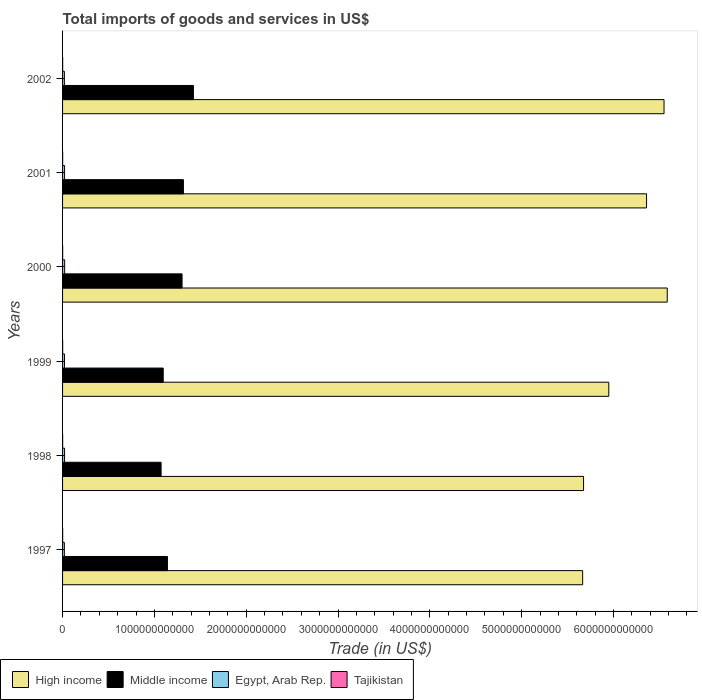How many bars are there on the 5th tick from the top?
Your answer should be compact. 4. How many bars are there on the 4th tick from the bottom?
Your response must be concise. 4. What is the total imports of goods and services in High income in 2000?
Your answer should be compact. 6.59e+12. Across all years, what is the maximum total imports of goods and services in Egypt, Arab Rep.?
Offer a terse response. 2.28e+1. Across all years, what is the minimum total imports of goods and services in Tajikistan?
Provide a short and direct response. 7.33e+08. In which year was the total imports of goods and services in Middle income minimum?
Offer a very short reply. 1998. What is the total total imports of goods and services in Middle income in the graph?
Your answer should be very brief. 7.35e+12. What is the difference between the total imports of goods and services in Tajikistan in 1999 and that in 2002?
Offer a very short reply. -1.96e+08. What is the difference between the total imports of goods and services in Tajikistan in 1998 and the total imports of goods and services in Egypt, Arab Rep. in 2002?
Provide a short and direct response. -1.92e+1. What is the average total imports of goods and services in High income per year?
Ensure brevity in your answer.  6.13e+12. In the year 2000, what is the difference between the total imports of goods and services in High income and total imports of goods and services in Egypt, Arab Rep.?
Ensure brevity in your answer.  6.56e+12. In how many years, is the total imports of goods and services in Egypt, Arab Rep. greater than 5600000000000 US$?
Provide a short and direct response. 0. What is the ratio of the total imports of goods and services in Tajikistan in 2001 to that in 2002?
Offer a very short reply. 0.91. Is the total imports of goods and services in Tajikistan in 1998 less than that in 2000?
Your answer should be compact. Yes. Is the difference between the total imports of goods and services in High income in 1997 and 2000 greater than the difference between the total imports of goods and services in Egypt, Arab Rep. in 1997 and 2000?
Your answer should be very brief. No. What is the difference between the highest and the second highest total imports of goods and services in High income?
Keep it short and to the point. 3.51e+1. What is the difference between the highest and the lowest total imports of goods and services in Middle income?
Your answer should be compact. 3.52e+11. Is the sum of the total imports of goods and services in Egypt, Arab Rep. in 1998 and 1999 greater than the maximum total imports of goods and services in Middle income across all years?
Keep it short and to the point. No. What does the 1st bar from the top in 2002 represents?
Provide a succinct answer. Tajikistan. Is it the case that in every year, the sum of the total imports of goods and services in High income and total imports of goods and services in Tajikistan is greater than the total imports of goods and services in Egypt, Arab Rep.?
Make the answer very short. Yes. How many bars are there?
Offer a very short reply. 24. How many years are there in the graph?
Offer a terse response. 6. What is the difference between two consecutive major ticks on the X-axis?
Offer a terse response. 1.00e+12. Does the graph contain grids?
Offer a terse response. No. Where does the legend appear in the graph?
Give a very brief answer. Bottom left. What is the title of the graph?
Offer a very short reply. Total imports of goods and services in US$. What is the label or title of the X-axis?
Your response must be concise. Trade (in US$). What is the Trade (in US$) of High income in 1997?
Keep it short and to the point. 5.66e+12. What is the Trade (in US$) in Middle income in 1997?
Provide a short and direct response. 1.14e+12. What is the Trade (in US$) in Egypt, Arab Rep. in 1997?
Make the answer very short. 1.95e+1. What is the Trade (in US$) in Tajikistan in 1997?
Your answer should be very brief. 8.66e+08. What is the Trade (in US$) of High income in 1998?
Your answer should be compact. 5.67e+12. What is the Trade (in US$) in Middle income in 1998?
Your answer should be compact. 1.07e+12. What is the Trade (in US$) of Egypt, Arab Rep. in 1998?
Make the answer very short. 2.18e+1. What is the Trade (in US$) of Tajikistan in 1998?
Ensure brevity in your answer.  7.66e+08. What is the Trade (in US$) of High income in 1999?
Your answer should be compact. 5.95e+12. What is the Trade (in US$) of Middle income in 1999?
Provide a short and direct response. 1.10e+12. What is the Trade (in US$) of Egypt, Arab Rep. in 1999?
Keep it short and to the point. 2.11e+1. What is the Trade (in US$) of Tajikistan in 1999?
Ensure brevity in your answer.  7.33e+08. What is the Trade (in US$) in High income in 2000?
Provide a succinct answer. 6.59e+12. What is the Trade (in US$) of Middle income in 2000?
Make the answer very short. 1.30e+12. What is the Trade (in US$) in Egypt, Arab Rep. in 2000?
Offer a very short reply. 2.28e+1. What is the Trade (in US$) in Tajikistan in 2000?
Offer a very short reply. 8.68e+08. What is the Trade (in US$) of High income in 2001?
Provide a succinct answer. 6.36e+12. What is the Trade (in US$) of Middle income in 2001?
Make the answer very short. 1.32e+12. What is the Trade (in US$) of Egypt, Arab Rep. in 2001?
Keep it short and to the point. 2.18e+1. What is the Trade (in US$) in Tajikistan in 2001?
Keep it short and to the point. 8.47e+08. What is the Trade (in US$) of High income in 2002?
Offer a very short reply. 6.55e+12. What is the Trade (in US$) in Middle income in 2002?
Give a very brief answer. 1.42e+12. What is the Trade (in US$) of Egypt, Arab Rep. in 2002?
Offer a very short reply. 1.99e+1. What is the Trade (in US$) of Tajikistan in 2002?
Your response must be concise. 9.29e+08. Across all years, what is the maximum Trade (in US$) of High income?
Make the answer very short. 6.59e+12. Across all years, what is the maximum Trade (in US$) in Middle income?
Your response must be concise. 1.42e+12. Across all years, what is the maximum Trade (in US$) of Egypt, Arab Rep.?
Ensure brevity in your answer.  2.28e+1. Across all years, what is the maximum Trade (in US$) of Tajikistan?
Make the answer very short. 9.29e+08. Across all years, what is the minimum Trade (in US$) of High income?
Give a very brief answer. 5.66e+12. Across all years, what is the minimum Trade (in US$) in Middle income?
Your response must be concise. 1.07e+12. Across all years, what is the minimum Trade (in US$) of Egypt, Arab Rep.?
Your response must be concise. 1.95e+1. Across all years, what is the minimum Trade (in US$) in Tajikistan?
Keep it short and to the point. 7.33e+08. What is the total Trade (in US$) of High income in the graph?
Provide a succinct answer. 3.68e+13. What is the total Trade (in US$) in Middle income in the graph?
Ensure brevity in your answer.  7.35e+12. What is the total Trade (in US$) of Egypt, Arab Rep. in the graph?
Ensure brevity in your answer.  1.27e+11. What is the total Trade (in US$) in Tajikistan in the graph?
Ensure brevity in your answer.  5.01e+09. What is the difference between the Trade (in US$) in High income in 1997 and that in 1998?
Offer a terse response. -9.92e+09. What is the difference between the Trade (in US$) in Middle income in 1997 and that in 1998?
Give a very brief answer. 6.91e+1. What is the difference between the Trade (in US$) of Egypt, Arab Rep. in 1997 and that in 1998?
Keep it short and to the point. -2.28e+09. What is the difference between the Trade (in US$) in Tajikistan in 1997 and that in 1998?
Keep it short and to the point. 9.98e+07. What is the difference between the Trade (in US$) of High income in 1997 and that in 1999?
Provide a short and direct response. -2.85e+11. What is the difference between the Trade (in US$) of Middle income in 1997 and that in 1999?
Keep it short and to the point. 4.58e+1. What is the difference between the Trade (in US$) in Egypt, Arab Rep. in 1997 and that in 1999?
Offer a terse response. -1.62e+09. What is the difference between the Trade (in US$) of Tajikistan in 1997 and that in 1999?
Ensure brevity in your answer.  1.32e+08. What is the difference between the Trade (in US$) of High income in 1997 and that in 2000?
Make the answer very short. -9.21e+11. What is the difference between the Trade (in US$) in Middle income in 1997 and that in 2000?
Your answer should be compact. -1.59e+11. What is the difference between the Trade (in US$) in Egypt, Arab Rep. in 1997 and that in 2000?
Give a very brief answer. -3.25e+09. What is the difference between the Trade (in US$) in Tajikistan in 1997 and that in 2000?
Offer a very short reply. -2.83e+06. What is the difference between the Trade (in US$) of High income in 1997 and that in 2001?
Provide a succinct answer. -6.96e+11. What is the difference between the Trade (in US$) in Middle income in 1997 and that in 2001?
Provide a succinct answer. -1.74e+11. What is the difference between the Trade (in US$) of Egypt, Arab Rep. in 1997 and that in 2001?
Your response must be concise. -2.27e+09. What is the difference between the Trade (in US$) of Tajikistan in 1997 and that in 2001?
Provide a succinct answer. 1.87e+07. What is the difference between the Trade (in US$) of High income in 1997 and that in 2002?
Your answer should be compact. -8.86e+11. What is the difference between the Trade (in US$) of Middle income in 1997 and that in 2002?
Your response must be concise. -2.83e+11. What is the difference between the Trade (in US$) of Egypt, Arab Rep. in 1997 and that in 2002?
Your answer should be compact. -3.89e+08. What is the difference between the Trade (in US$) in Tajikistan in 1997 and that in 2002?
Provide a succinct answer. -6.36e+07. What is the difference between the Trade (in US$) of High income in 1998 and that in 1999?
Your answer should be very brief. -2.75e+11. What is the difference between the Trade (in US$) of Middle income in 1998 and that in 1999?
Offer a very short reply. -2.33e+1. What is the difference between the Trade (in US$) of Egypt, Arab Rep. in 1998 and that in 1999?
Provide a short and direct response. 6.68e+08. What is the difference between the Trade (in US$) in Tajikistan in 1998 and that in 1999?
Ensure brevity in your answer.  3.23e+07. What is the difference between the Trade (in US$) of High income in 1998 and that in 2000?
Give a very brief answer. -9.12e+11. What is the difference between the Trade (in US$) of Middle income in 1998 and that in 2000?
Give a very brief answer. -2.28e+11. What is the difference between the Trade (in US$) in Egypt, Arab Rep. in 1998 and that in 2000?
Your answer should be compact. -9.68e+08. What is the difference between the Trade (in US$) of Tajikistan in 1998 and that in 2000?
Make the answer very short. -1.03e+08. What is the difference between the Trade (in US$) of High income in 1998 and that in 2001?
Your answer should be very brief. -6.86e+11. What is the difference between the Trade (in US$) of Middle income in 1998 and that in 2001?
Give a very brief answer. -2.43e+11. What is the difference between the Trade (in US$) in Egypt, Arab Rep. in 1998 and that in 2001?
Make the answer very short. 1.04e+07. What is the difference between the Trade (in US$) in Tajikistan in 1998 and that in 2001?
Keep it short and to the point. -8.11e+07. What is the difference between the Trade (in US$) of High income in 1998 and that in 2002?
Provide a succinct answer. -8.76e+11. What is the difference between the Trade (in US$) in Middle income in 1998 and that in 2002?
Offer a very short reply. -3.52e+11. What is the difference between the Trade (in US$) of Egypt, Arab Rep. in 1998 and that in 2002?
Your answer should be compact. 1.90e+09. What is the difference between the Trade (in US$) of Tajikistan in 1998 and that in 2002?
Offer a terse response. -1.63e+08. What is the difference between the Trade (in US$) of High income in 1999 and that in 2000?
Provide a short and direct response. -6.37e+11. What is the difference between the Trade (in US$) of Middle income in 1999 and that in 2000?
Provide a short and direct response. -2.05e+11. What is the difference between the Trade (in US$) of Egypt, Arab Rep. in 1999 and that in 2000?
Your response must be concise. -1.64e+09. What is the difference between the Trade (in US$) of Tajikistan in 1999 and that in 2000?
Make the answer very short. -1.35e+08. What is the difference between the Trade (in US$) of High income in 1999 and that in 2001?
Your response must be concise. -4.11e+11. What is the difference between the Trade (in US$) in Middle income in 1999 and that in 2001?
Your answer should be compact. -2.20e+11. What is the difference between the Trade (in US$) of Egypt, Arab Rep. in 1999 and that in 2001?
Make the answer very short. -6.58e+08. What is the difference between the Trade (in US$) in Tajikistan in 1999 and that in 2001?
Offer a very short reply. -1.13e+08. What is the difference between the Trade (in US$) in High income in 1999 and that in 2002?
Offer a terse response. -6.02e+11. What is the difference between the Trade (in US$) of Middle income in 1999 and that in 2002?
Provide a succinct answer. -3.29e+11. What is the difference between the Trade (in US$) of Egypt, Arab Rep. in 1999 and that in 2002?
Offer a terse response. 1.23e+09. What is the difference between the Trade (in US$) of Tajikistan in 1999 and that in 2002?
Your response must be concise. -1.96e+08. What is the difference between the Trade (in US$) of High income in 2000 and that in 2001?
Give a very brief answer. 2.26e+11. What is the difference between the Trade (in US$) of Middle income in 2000 and that in 2001?
Offer a terse response. -1.48e+1. What is the difference between the Trade (in US$) in Egypt, Arab Rep. in 2000 and that in 2001?
Provide a succinct answer. 9.78e+08. What is the difference between the Trade (in US$) in Tajikistan in 2000 and that in 2001?
Offer a very short reply. 2.15e+07. What is the difference between the Trade (in US$) of High income in 2000 and that in 2002?
Make the answer very short. 3.51e+1. What is the difference between the Trade (in US$) of Middle income in 2000 and that in 2002?
Ensure brevity in your answer.  -1.24e+11. What is the difference between the Trade (in US$) in Egypt, Arab Rep. in 2000 and that in 2002?
Keep it short and to the point. 2.86e+09. What is the difference between the Trade (in US$) in Tajikistan in 2000 and that in 2002?
Your answer should be very brief. -6.08e+07. What is the difference between the Trade (in US$) in High income in 2001 and that in 2002?
Your response must be concise. -1.90e+11. What is the difference between the Trade (in US$) in Middle income in 2001 and that in 2002?
Provide a short and direct response. -1.09e+11. What is the difference between the Trade (in US$) of Egypt, Arab Rep. in 2001 and that in 2002?
Provide a short and direct response. 1.89e+09. What is the difference between the Trade (in US$) of Tajikistan in 2001 and that in 2002?
Your answer should be compact. -8.23e+07. What is the difference between the Trade (in US$) of High income in 1997 and the Trade (in US$) of Middle income in 1998?
Your answer should be compact. 4.59e+12. What is the difference between the Trade (in US$) of High income in 1997 and the Trade (in US$) of Egypt, Arab Rep. in 1998?
Your response must be concise. 5.64e+12. What is the difference between the Trade (in US$) in High income in 1997 and the Trade (in US$) in Tajikistan in 1998?
Keep it short and to the point. 5.66e+12. What is the difference between the Trade (in US$) of Middle income in 1997 and the Trade (in US$) of Egypt, Arab Rep. in 1998?
Your answer should be very brief. 1.12e+12. What is the difference between the Trade (in US$) in Middle income in 1997 and the Trade (in US$) in Tajikistan in 1998?
Provide a short and direct response. 1.14e+12. What is the difference between the Trade (in US$) in Egypt, Arab Rep. in 1997 and the Trade (in US$) in Tajikistan in 1998?
Your response must be concise. 1.88e+1. What is the difference between the Trade (in US$) in High income in 1997 and the Trade (in US$) in Middle income in 1999?
Your answer should be very brief. 4.57e+12. What is the difference between the Trade (in US$) of High income in 1997 and the Trade (in US$) of Egypt, Arab Rep. in 1999?
Ensure brevity in your answer.  5.64e+12. What is the difference between the Trade (in US$) of High income in 1997 and the Trade (in US$) of Tajikistan in 1999?
Offer a very short reply. 5.66e+12. What is the difference between the Trade (in US$) in Middle income in 1997 and the Trade (in US$) in Egypt, Arab Rep. in 1999?
Your answer should be compact. 1.12e+12. What is the difference between the Trade (in US$) of Middle income in 1997 and the Trade (in US$) of Tajikistan in 1999?
Your answer should be very brief. 1.14e+12. What is the difference between the Trade (in US$) of Egypt, Arab Rep. in 1997 and the Trade (in US$) of Tajikistan in 1999?
Your response must be concise. 1.88e+1. What is the difference between the Trade (in US$) in High income in 1997 and the Trade (in US$) in Middle income in 2000?
Ensure brevity in your answer.  4.36e+12. What is the difference between the Trade (in US$) of High income in 1997 and the Trade (in US$) of Egypt, Arab Rep. in 2000?
Ensure brevity in your answer.  5.64e+12. What is the difference between the Trade (in US$) of High income in 1997 and the Trade (in US$) of Tajikistan in 2000?
Your response must be concise. 5.66e+12. What is the difference between the Trade (in US$) of Middle income in 1997 and the Trade (in US$) of Egypt, Arab Rep. in 2000?
Your answer should be very brief. 1.12e+12. What is the difference between the Trade (in US$) in Middle income in 1997 and the Trade (in US$) in Tajikistan in 2000?
Offer a very short reply. 1.14e+12. What is the difference between the Trade (in US$) in Egypt, Arab Rep. in 1997 and the Trade (in US$) in Tajikistan in 2000?
Provide a short and direct response. 1.87e+1. What is the difference between the Trade (in US$) in High income in 1997 and the Trade (in US$) in Middle income in 2001?
Ensure brevity in your answer.  4.35e+12. What is the difference between the Trade (in US$) of High income in 1997 and the Trade (in US$) of Egypt, Arab Rep. in 2001?
Offer a terse response. 5.64e+12. What is the difference between the Trade (in US$) in High income in 1997 and the Trade (in US$) in Tajikistan in 2001?
Make the answer very short. 5.66e+12. What is the difference between the Trade (in US$) of Middle income in 1997 and the Trade (in US$) of Egypt, Arab Rep. in 2001?
Provide a succinct answer. 1.12e+12. What is the difference between the Trade (in US$) of Middle income in 1997 and the Trade (in US$) of Tajikistan in 2001?
Offer a terse response. 1.14e+12. What is the difference between the Trade (in US$) in Egypt, Arab Rep. in 1997 and the Trade (in US$) in Tajikistan in 2001?
Keep it short and to the point. 1.87e+1. What is the difference between the Trade (in US$) of High income in 1997 and the Trade (in US$) of Middle income in 2002?
Provide a short and direct response. 4.24e+12. What is the difference between the Trade (in US$) in High income in 1997 and the Trade (in US$) in Egypt, Arab Rep. in 2002?
Your answer should be very brief. 5.64e+12. What is the difference between the Trade (in US$) of High income in 1997 and the Trade (in US$) of Tajikistan in 2002?
Give a very brief answer. 5.66e+12. What is the difference between the Trade (in US$) of Middle income in 1997 and the Trade (in US$) of Egypt, Arab Rep. in 2002?
Give a very brief answer. 1.12e+12. What is the difference between the Trade (in US$) of Middle income in 1997 and the Trade (in US$) of Tajikistan in 2002?
Offer a terse response. 1.14e+12. What is the difference between the Trade (in US$) of Egypt, Arab Rep. in 1997 and the Trade (in US$) of Tajikistan in 2002?
Offer a terse response. 1.86e+1. What is the difference between the Trade (in US$) of High income in 1998 and the Trade (in US$) of Middle income in 1999?
Keep it short and to the point. 4.58e+12. What is the difference between the Trade (in US$) of High income in 1998 and the Trade (in US$) of Egypt, Arab Rep. in 1999?
Offer a very short reply. 5.65e+12. What is the difference between the Trade (in US$) in High income in 1998 and the Trade (in US$) in Tajikistan in 1999?
Offer a very short reply. 5.67e+12. What is the difference between the Trade (in US$) of Middle income in 1998 and the Trade (in US$) of Egypt, Arab Rep. in 1999?
Offer a terse response. 1.05e+12. What is the difference between the Trade (in US$) in Middle income in 1998 and the Trade (in US$) in Tajikistan in 1999?
Your answer should be very brief. 1.07e+12. What is the difference between the Trade (in US$) in Egypt, Arab Rep. in 1998 and the Trade (in US$) in Tajikistan in 1999?
Your answer should be very brief. 2.11e+1. What is the difference between the Trade (in US$) of High income in 1998 and the Trade (in US$) of Middle income in 2000?
Your response must be concise. 4.37e+12. What is the difference between the Trade (in US$) of High income in 1998 and the Trade (in US$) of Egypt, Arab Rep. in 2000?
Make the answer very short. 5.65e+12. What is the difference between the Trade (in US$) of High income in 1998 and the Trade (in US$) of Tajikistan in 2000?
Offer a very short reply. 5.67e+12. What is the difference between the Trade (in US$) of Middle income in 1998 and the Trade (in US$) of Egypt, Arab Rep. in 2000?
Offer a very short reply. 1.05e+12. What is the difference between the Trade (in US$) of Middle income in 1998 and the Trade (in US$) of Tajikistan in 2000?
Make the answer very short. 1.07e+12. What is the difference between the Trade (in US$) in Egypt, Arab Rep. in 1998 and the Trade (in US$) in Tajikistan in 2000?
Your response must be concise. 2.09e+1. What is the difference between the Trade (in US$) of High income in 1998 and the Trade (in US$) of Middle income in 2001?
Your answer should be compact. 4.36e+12. What is the difference between the Trade (in US$) in High income in 1998 and the Trade (in US$) in Egypt, Arab Rep. in 2001?
Keep it short and to the point. 5.65e+12. What is the difference between the Trade (in US$) of High income in 1998 and the Trade (in US$) of Tajikistan in 2001?
Your response must be concise. 5.67e+12. What is the difference between the Trade (in US$) in Middle income in 1998 and the Trade (in US$) in Egypt, Arab Rep. in 2001?
Provide a succinct answer. 1.05e+12. What is the difference between the Trade (in US$) in Middle income in 1998 and the Trade (in US$) in Tajikistan in 2001?
Your answer should be compact. 1.07e+12. What is the difference between the Trade (in US$) in Egypt, Arab Rep. in 1998 and the Trade (in US$) in Tajikistan in 2001?
Give a very brief answer. 2.10e+1. What is the difference between the Trade (in US$) in High income in 1998 and the Trade (in US$) in Middle income in 2002?
Your response must be concise. 4.25e+12. What is the difference between the Trade (in US$) in High income in 1998 and the Trade (in US$) in Egypt, Arab Rep. in 2002?
Your response must be concise. 5.65e+12. What is the difference between the Trade (in US$) of High income in 1998 and the Trade (in US$) of Tajikistan in 2002?
Make the answer very short. 5.67e+12. What is the difference between the Trade (in US$) in Middle income in 1998 and the Trade (in US$) in Egypt, Arab Rep. in 2002?
Your response must be concise. 1.05e+12. What is the difference between the Trade (in US$) in Middle income in 1998 and the Trade (in US$) in Tajikistan in 2002?
Offer a very short reply. 1.07e+12. What is the difference between the Trade (in US$) of Egypt, Arab Rep. in 1998 and the Trade (in US$) of Tajikistan in 2002?
Your answer should be compact. 2.09e+1. What is the difference between the Trade (in US$) of High income in 1999 and the Trade (in US$) of Middle income in 2000?
Keep it short and to the point. 4.65e+12. What is the difference between the Trade (in US$) of High income in 1999 and the Trade (in US$) of Egypt, Arab Rep. in 2000?
Provide a succinct answer. 5.93e+12. What is the difference between the Trade (in US$) of High income in 1999 and the Trade (in US$) of Tajikistan in 2000?
Ensure brevity in your answer.  5.95e+12. What is the difference between the Trade (in US$) of Middle income in 1999 and the Trade (in US$) of Egypt, Arab Rep. in 2000?
Provide a short and direct response. 1.07e+12. What is the difference between the Trade (in US$) in Middle income in 1999 and the Trade (in US$) in Tajikistan in 2000?
Your answer should be very brief. 1.10e+12. What is the difference between the Trade (in US$) of Egypt, Arab Rep. in 1999 and the Trade (in US$) of Tajikistan in 2000?
Offer a terse response. 2.03e+1. What is the difference between the Trade (in US$) of High income in 1999 and the Trade (in US$) of Middle income in 2001?
Provide a short and direct response. 4.63e+12. What is the difference between the Trade (in US$) in High income in 1999 and the Trade (in US$) in Egypt, Arab Rep. in 2001?
Your answer should be very brief. 5.93e+12. What is the difference between the Trade (in US$) in High income in 1999 and the Trade (in US$) in Tajikistan in 2001?
Your response must be concise. 5.95e+12. What is the difference between the Trade (in US$) in Middle income in 1999 and the Trade (in US$) in Egypt, Arab Rep. in 2001?
Offer a very short reply. 1.07e+12. What is the difference between the Trade (in US$) in Middle income in 1999 and the Trade (in US$) in Tajikistan in 2001?
Offer a very short reply. 1.10e+12. What is the difference between the Trade (in US$) of Egypt, Arab Rep. in 1999 and the Trade (in US$) of Tajikistan in 2001?
Make the answer very short. 2.03e+1. What is the difference between the Trade (in US$) in High income in 1999 and the Trade (in US$) in Middle income in 2002?
Keep it short and to the point. 4.52e+12. What is the difference between the Trade (in US$) in High income in 1999 and the Trade (in US$) in Egypt, Arab Rep. in 2002?
Give a very brief answer. 5.93e+12. What is the difference between the Trade (in US$) in High income in 1999 and the Trade (in US$) in Tajikistan in 2002?
Make the answer very short. 5.95e+12. What is the difference between the Trade (in US$) in Middle income in 1999 and the Trade (in US$) in Egypt, Arab Rep. in 2002?
Provide a short and direct response. 1.08e+12. What is the difference between the Trade (in US$) in Middle income in 1999 and the Trade (in US$) in Tajikistan in 2002?
Provide a short and direct response. 1.10e+12. What is the difference between the Trade (in US$) in Egypt, Arab Rep. in 1999 and the Trade (in US$) in Tajikistan in 2002?
Provide a short and direct response. 2.02e+1. What is the difference between the Trade (in US$) in High income in 2000 and the Trade (in US$) in Middle income in 2001?
Keep it short and to the point. 5.27e+12. What is the difference between the Trade (in US$) of High income in 2000 and the Trade (in US$) of Egypt, Arab Rep. in 2001?
Ensure brevity in your answer.  6.56e+12. What is the difference between the Trade (in US$) in High income in 2000 and the Trade (in US$) in Tajikistan in 2001?
Provide a short and direct response. 6.58e+12. What is the difference between the Trade (in US$) in Middle income in 2000 and the Trade (in US$) in Egypt, Arab Rep. in 2001?
Make the answer very short. 1.28e+12. What is the difference between the Trade (in US$) of Middle income in 2000 and the Trade (in US$) of Tajikistan in 2001?
Your answer should be compact. 1.30e+12. What is the difference between the Trade (in US$) in Egypt, Arab Rep. in 2000 and the Trade (in US$) in Tajikistan in 2001?
Your answer should be very brief. 2.19e+1. What is the difference between the Trade (in US$) in High income in 2000 and the Trade (in US$) in Middle income in 2002?
Ensure brevity in your answer.  5.16e+12. What is the difference between the Trade (in US$) of High income in 2000 and the Trade (in US$) of Egypt, Arab Rep. in 2002?
Give a very brief answer. 6.57e+12. What is the difference between the Trade (in US$) in High income in 2000 and the Trade (in US$) in Tajikistan in 2002?
Your answer should be compact. 6.58e+12. What is the difference between the Trade (in US$) in Middle income in 2000 and the Trade (in US$) in Egypt, Arab Rep. in 2002?
Provide a short and direct response. 1.28e+12. What is the difference between the Trade (in US$) of Middle income in 2000 and the Trade (in US$) of Tajikistan in 2002?
Offer a terse response. 1.30e+12. What is the difference between the Trade (in US$) in Egypt, Arab Rep. in 2000 and the Trade (in US$) in Tajikistan in 2002?
Your answer should be very brief. 2.19e+1. What is the difference between the Trade (in US$) in High income in 2001 and the Trade (in US$) in Middle income in 2002?
Offer a very short reply. 4.94e+12. What is the difference between the Trade (in US$) of High income in 2001 and the Trade (in US$) of Egypt, Arab Rep. in 2002?
Offer a very short reply. 6.34e+12. What is the difference between the Trade (in US$) in High income in 2001 and the Trade (in US$) in Tajikistan in 2002?
Give a very brief answer. 6.36e+12. What is the difference between the Trade (in US$) in Middle income in 2001 and the Trade (in US$) in Egypt, Arab Rep. in 2002?
Keep it short and to the point. 1.30e+12. What is the difference between the Trade (in US$) in Middle income in 2001 and the Trade (in US$) in Tajikistan in 2002?
Offer a very short reply. 1.32e+12. What is the difference between the Trade (in US$) in Egypt, Arab Rep. in 2001 and the Trade (in US$) in Tajikistan in 2002?
Give a very brief answer. 2.09e+1. What is the average Trade (in US$) in High income per year?
Offer a terse response. 6.13e+12. What is the average Trade (in US$) in Middle income per year?
Provide a short and direct response. 1.23e+12. What is the average Trade (in US$) in Egypt, Arab Rep. per year?
Provide a short and direct response. 2.12e+1. What is the average Trade (in US$) in Tajikistan per year?
Your response must be concise. 8.35e+08. In the year 1997, what is the difference between the Trade (in US$) of High income and Trade (in US$) of Middle income?
Give a very brief answer. 4.52e+12. In the year 1997, what is the difference between the Trade (in US$) in High income and Trade (in US$) in Egypt, Arab Rep.?
Ensure brevity in your answer.  5.64e+12. In the year 1997, what is the difference between the Trade (in US$) in High income and Trade (in US$) in Tajikistan?
Give a very brief answer. 5.66e+12. In the year 1997, what is the difference between the Trade (in US$) in Middle income and Trade (in US$) in Egypt, Arab Rep.?
Give a very brief answer. 1.12e+12. In the year 1997, what is the difference between the Trade (in US$) of Middle income and Trade (in US$) of Tajikistan?
Provide a short and direct response. 1.14e+12. In the year 1997, what is the difference between the Trade (in US$) of Egypt, Arab Rep. and Trade (in US$) of Tajikistan?
Your response must be concise. 1.87e+1. In the year 1998, what is the difference between the Trade (in US$) in High income and Trade (in US$) in Middle income?
Provide a short and direct response. 4.60e+12. In the year 1998, what is the difference between the Trade (in US$) in High income and Trade (in US$) in Egypt, Arab Rep.?
Your response must be concise. 5.65e+12. In the year 1998, what is the difference between the Trade (in US$) of High income and Trade (in US$) of Tajikistan?
Your answer should be very brief. 5.67e+12. In the year 1998, what is the difference between the Trade (in US$) of Middle income and Trade (in US$) of Egypt, Arab Rep.?
Make the answer very short. 1.05e+12. In the year 1998, what is the difference between the Trade (in US$) in Middle income and Trade (in US$) in Tajikistan?
Make the answer very short. 1.07e+12. In the year 1998, what is the difference between the Trade (in US$) of Egypt, Arab Rep. and Trade (in US$) of Tajikistan?
Provide a short and direct response. 2.10e+1. In the year 1999, what is the difference between the Trade (in US$) in High income and Trade (in US$) in Middle income?
Provide a succinct answer. 4.85e+12. In the year 1999, what is the difference between the Trade (in US$) in High income and Trade (in US$) in Egypt, Arab Rep.?
Keep it short and to the point. 5.93e+12. In the year 1999, what is the difference between the Trade (in US$) of High income and Trade (in US$) of Tajikistan?
Provide a succinct answer. 5.95e+12. In the year 1999, what is the difference between the Trade (in US$) in Middle income and Trade (in US$) in Egypt, Arab Rep.?
Provide a short and direct response. 1.08e+12. In the year 1999, what is the difference between the Trade (in US$) in Middle income and Trade (in US$) in Tajikistan?
Ensure brevity in your answer.  1.10e+12. In the year 1999, what is the difference between the Trade (in US$) of Egypt, Arab Rep. and Trade (in US$) of Tajikistan?
Keep it short and to the point. 2.04e+1. In the year 2000, what is the difference between the Trade (in US$) of High income and Trade (in US$) of Middle income?
Your answer should be very brief. 5.28e+12. In the year 2000, what is the difference between the Trade (in US$) in High income and Trade (in US$) in Egypt, Arab Rep.?
Make the answer very short. 6.56e+12. In the year 2000, what is the difference between the Trade (in US$) in High income and Trade (in US$) in Tajikistan?
Your answer should be compact. 6.58e+12. In the year 2000, what is the difference between the Trade (in US$) in Middle income and Trade (in US$) in Egypt, Arab Rep.?
Provide a short and direct response. 1.28e+12. In the year 2000, what is the difference between the Trade (in US$) of Middle income and Trade (in US$) of Tajikistan?
Offer a terse response. 1.30e+12. In the year 2000, what is the difference between the Trade (in US$) of Egypt, Arab Rep. and Trade (in US$) of Tajikistan?
Offer a very short reply. 2.19e+1. In the year 2001, what is the difference between the Trade (in US$) in High income and Trade (in US$) in Middle income?
Make the answer very short. 5.04e+12. In the year 2001, what is the difference between the Trade (in US$) in High income and Trade (in US$) in Egypt, Arab Rep.?
Give a very brief answer. 6.34e+12. In the year 2001, what is the difference between the Trade (in US$) in High income and Trade (in US$) in Tajikistan?
Ensure brevity in your answer.  6.36e+12. In the year 2001, what is the difference between the Trade (in US$) of Middle income and Trade (in US$) of Egypt, Arab Rep.?
Offer a very short reply. 1.29e+12. In the year 2001, what is the difference between the Trade (in US$) of Middle income and Trade (in US$) of Tajikistan?
Your response must be concise. 1.32e+12. In the year 2001, what is the difference between the Trade (in US$) in Egypt, Arab Rep. and Trade (in US$) in Tajikistan?
Give a very brief answer. 2.10e+1. In the year 2002, what is the difference between the Trade (in US$) in High income and Trade (in US$) in Middle income?
Offer a terse response. 5.13e+12. In the year 2002, what is the difference between the Trade (in US$) in High income and Trade (in US$) in Egypt, Arab Rep.?
Provide a succinct answer. 6.53e+12. In the year 2002, what is the difference between the Trade (in US$) in High income and Trade (in US$) in Tajikistan?
Keep it short and to the point. 6.55e+12. In the year 2002, what is the difference between the Trade (in US$) in Middle income and Trade (in US$) in Egypt, Arab Rep.?
Provide a short and direct response. 1.41e+12. In the year 2002, what is the difference between the Trade (in US$) in Middle income and Trade (in US$) in Tajikistan?
Your answer should be very brief. 1.42e+12. In the year 2002, what is the difference between the Trade (in US$) in Egypt, Arab Rep. and Trade (in US$) in Tajikistan?
Ensure brevity in your answer.  1.90e+1. What is the ratio of the Trade (in US$) in High income in 1997 to that in 1998?
Provide a short and direct response. 1. What is the ratio of the Trade (in US$) of Middle income in 1997 to that in 1998?
Give a very brief answer. 1.06. What is the ratio of the Trade (in US$) in Egypt, Arab Rep. in 1997 to that in 1998?
Your response must be concise. 0.9. What is the ratio of the Trade (in US$) of Tajikistan in 1997 to that in 1998?
Ensure brevity in your answer.  1.13. What is the ratio of the Trade (in US$) of High income in 1997 to that in 1999?
Keep it short and to the point. 0.95. What is the ratio of the Trade (in US$) of Middle income in 1997 to that in 1999?
Offer a very short reply. 1.04. What is the ratio of the Trade (in US$) of Egypt, Arab Rep. in 1997 to that in 1999?
Your answer should be compact. 0.92. What is the ratio of the Trade (in US$) of Tajikistan in 1997 to that in 1999?
Provide a succinct answer. 1.18. What is the ratio of the Trade (in US$) in High income in 1997 to that in 2000?
Keep it short and to the point. 0.86. What is the ratio of the Trade (in US$) in Middle income in 1997 to that in 2000?
Offer a terse response. 0.88. What is the ratio of the Trade (in US$) in Egypt, Arab Rep. in 1997 to that in 2000?
Keep it short and to the point. 0.86. What is the ratio of the Trade (in US$) in Tajikistan in 1997 to that in 2000?
Your answer should be very brief. 1. What is the ratio of the Trade (in US$) of High income in 1997 to that in 2001?
Make the answer very short. 0.89. What is the ratio of the Trade (in US$) of Middle income in 1997 to that in 2001?
Your response must be concise. 0.87. What is the ratio of the Trade (in US$) in Egypt, Arab Rep. in 1997 to that in 2001?
Ensure brevity in your answer.  0.9. What is the ratio of the Trade (in US$) of Tajikistan in 1997 to that in 2001?
Offer a terse response. 1.02. What is the ratio of the Trade (in US$) of High income in 1997 to that in 2002?
Offer a very short reply. 0.86. What is the ratio of the Trade (in US$) of Middle income in 1997 to that in 2002?
Your answer should be very brief. 0.8. What is the ratio of the Trade (in US$) in Egypt, Arab Rep. in 1997 to that in 2002?
Give a very brief answer. 0.98. What is the ratio of the Trade (in US$) in Tajikistan in 1997 to that in 2002?
Make the answer very short. 0.93. What is the ratio of the Trade (in US$) of High income in 1998 to that in 1999?
Give a very brief answer. 0.95. What is the ratio of the Trade (in US$) of Middle income in 1998 to that in 1999?
Keep it short and to the point. 0.98. What is the ratio of the Trade (in US$) of Egypt, Arab Rep. in 1998 to that in 1999?
Your response must be concise. 1.03. What is the ratio of the Trade (in US$) of Tajikistan in 1998 to that in 1999?
Provide a short and direct response. 1.04. What is the ratio of the Trade (in US$) of High income in 1998 to that in 2000?
Make the answer very short. 0.86. What is the ratio of the Trade (in US$) of Middle income in 1998 to that in 2000?
Your answer should be compact. 0.82. What is the ratio of the Trade (in US$) of Egypt, Arab Rep. in 1998 to that in 2000?
Provide a short and direct response. 0.96. What is the ratio of the Trade (in US$) in Tajikistan in 1998 to that in 2000?
Keep it short and to the point. 0.88. What is the ratio of the Trade (in US$) of High income in 1998 to that in 2001?
Keep it short and to the point. 0.89. What is the ratio of the Trade (in US$) in Middle income in 1998 to that in 2001?
Provide a succinct answer. 0.82. What is the ratio of the Trade (in US$) of Tajikistan in 1998 to that in 2001?
Offer a terse response. 0.9. What is the ratio of the Trade (in US$) in High income in 1998 to that in 2002?
Your answer should be compact. 0.87. What is the ratio of the Trade (in US$) in Middle income in 1998 to that in 2002?
Your response must be concise. 0.75. What is the ratio of the Trade (in US$) of Egypt, Arab Rep. in 1998 to that in 2002?
Provide a short and direct response. 1.1. What is the ratio of the Trade (in US$) in Tajikistan in 1998 to that in 2002?
Offer a very short reply. 0.82. What is the ratio of the Trade (in US$) of High income in 1999 to that in 2000?
Make the answer very short. 0.9. What is the ratio of the Trade (in US$) in Middle income in 1999 to that in 2000?
Provide a succinct answer. 0.84. What is the ratio of the Trade (in US$) of Egypt, Arab Rep. in 1999 to that in 2000?
Your answer should be very brief. 0.93. What is the ratio of the Trade (in US$) in Tajikistan in 1999 to that in 2000?
Offer a very short reply. 0.84. What is the ratio of the Trade (in US$) in High income in 1999 to that in 2001?
Your answer should be compact. 0.94. What is the ratio of the Trade (in US$) of Middle income in 1999 to that in 2001?
Your answer should be very brief. 0.83. What is the ratio of the Trade (in US$) in Egypt, Arab Rep. in 1999 to that in 2001?
Your response must be concise. 0.97. What is the ratio of the Trade (in US$) in Tajikistan in 1999 to that in 2001?
Make the answer very short. 0.87. What is the ratio of the Trade (in US$) of High income in 1999 to that in 2002?
Make the answer very short. 0.91. What is the ratio of the Trade (in US$) in Middle income in 1999 to that in 2002?
Your answer should be very brief. 0.77. What is the ratio of the Trade (in US$) of Egypt, Arab Rep. in 1999 to that in 2002?
Offer a very short reply. 1.06. What is the ratio of the Trade (in US$) in Tajikistan in 1999 to that in 2002?
Make the answer very short. 0.79. What is the ratio of the Trade (in US$) of High income in 2000 to that in 2001?
Your answer should be compact. 1.04. What is the ratio of the Trade (in US$) of Egypt, Arab Rep. in 2000 to that in 2001?
Provide a succinct answer. 1.04. What is the ratio of the Trade (in US$) in Tajikistan in 2000 to that in 2001?
Provide a short and direct response. 1.03. What is the ratio of the Trade (in US$) of High income in 2000 to that in 2002?
Make the answer very short. 1.01. What is the ratio of the Trade (in US$) of Middle income in 2000 to that in 2002?
Give a very brief answer. 0.91. What is the ratio of the Trade (in US$) in Egypt, Arab Rep. in 2000 to that in 2002?
Your answer should be very brief. 1.14. What is the ratio of the Trade (in US$) in Tajikistan in 2000 to that in 2002?
Keep it short and to the point. 0.93. What is the ratio of the Trade (in US$) of High income in 2001 to that in 2002?
Ensure brevity in your answer.  0.97. What is the ratio of the Trade (in US$) in Middle income in 2001 to that in 2002?
Ensure brevity in your answer.  0.92. What is the ratio of the Trade (in US$) of Egypt, Arab Rep. in 2001 to that in 2002?
Keep it short and to the point. 1.09. What is the ratio of the Trade (in US$) of Tajikistan in 2001 to that in 2002?
Ensure brevity in your answer.  0.91. What is the difference between the highest and the second highest Trade (in US$) in High income?
Your answer should be very brief. 3.51e+1. What is the difference between the highest and the second highest Trade (in US$) of Middle income?
Provide a succinct answer. 1.09e+11. What is the difference between the highest and the second highest Trade (in US$) in Egypt, Arab Rep.?
Your response must be concise. 9.68e+08. What is the difference between the highest and the second highest Trade (in US$) of Tajikistan?
Provide a succinct answer. 6.08e+07. What is the difference between the highest and the lowest Trade (in US$) in High income?
Offer a very short reply. 9.21e+11. What is the difference between the highest and the lowest Trade (in US$) in Middle income?
Give a very brief answer. 3.52e+11. What is the difference between the highest and the lowest Trade (in US$) of Egypt, Arab Rep.?
Provide a short and direct response. 3.25e+09. What is the difference between the highest and the lowest Trade (in US$) of Tajikistan?
Keep it short and to the point. 1.96e+08. 